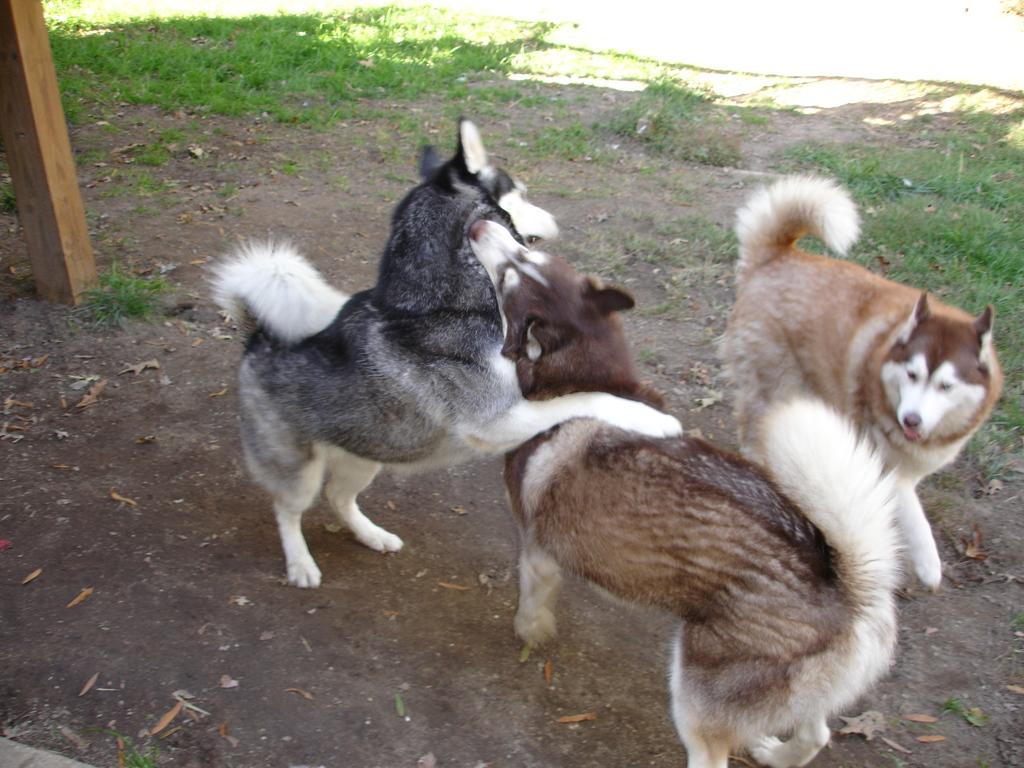How many dogs are in the image? There are three miniature Siberian husky dogs in the image. What is the position of the dogs in the image? The dogs are on the ground. What type of vegetation is visible in the background of the image? There is grass in the background of the image. What can be seen on the left side of the image? There is a pole on the left side of the image. What type of story is being told by the quilt in the image? There is no quilt present in the image, so no story can be told by a quilt. 